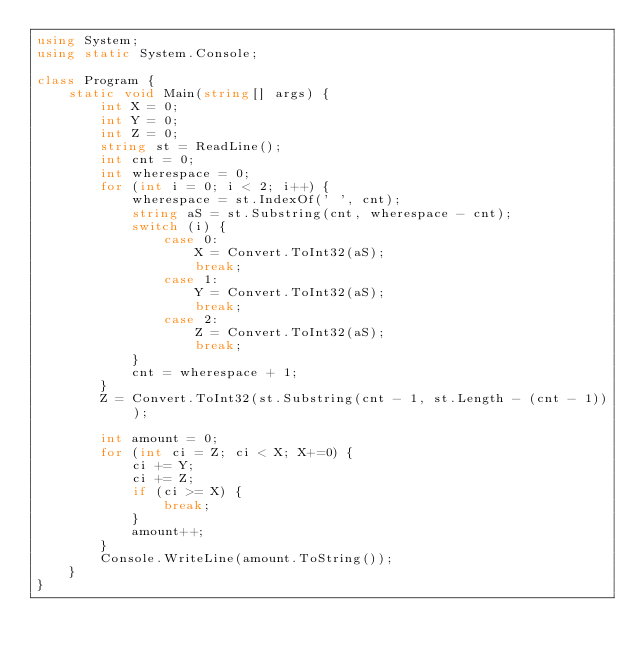<code> <loc_0><loc_0><loc_500><loc_500><_C#_>using System;
using static System.Console;

class Program {
    static void Main(string[] args) {
        int X = 0;
        int Y = 0;
        int Z = 0;
        string st = ReadLine();
        int cnt = 0;
        int wherespace = 0;
        for (int i = 0; i < 2; i++) {
            wherespace = st.IndexOf(' ', cnt);
            string aS = st.Substring(cnt, wherespace - cnt);
            switch (i) {
                case 0:
                    X = Convert.ToInt32(aS);
                    break;
                case 1:
                    Y = Convert.ToInt32(aS);
                    break;
                case 2:
                    Z = Convert.ToInt32(aS);
                    break;
            }
            cnt = wherespace + 1;
        }
        Z = Convert.ToInt32(st.Substring(cnt - 1, st.Length - (cnt - 1)));

        int amount = 0;
        for (int ci = Z; ci < X; X+=0) {
            ci += Y;
            ci += Z;
            if (ci >= X) {
                break;
            }
            amount++;
        }
        Console.WriteLine(amount.ToString());
    }
}</code> 